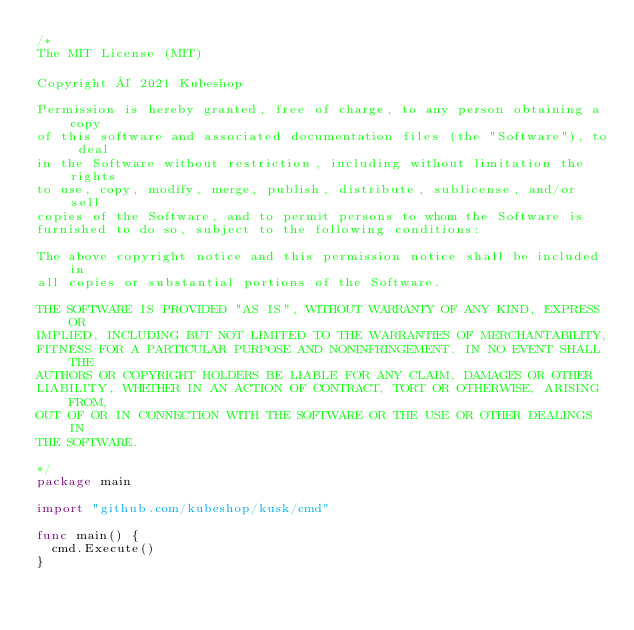<code> <loc_0><loc_0><loc_500><loc_500><_Go_>/*
The MIT License (MIT)

Copyright © 2021 Kubeshop

Permission is hereby granted, free of charge, to any person obtaining a copy
of this software and associated documentation files (the "Software"), to deal
in the Software without restriction, including without limitation the rights
to use, copy, modify, merge, publish, distribute, sublicense, and/or sell
copies of the Software, and to permit persons to whom the Software is
furnished to do so, subject to the following conditions:

The above copyright notice and this permission notice shall be included in
all copies or substantial portions of the Software.

THE SOFTWARE IS PROVIDED "AS IS", WITHOUT WARRANTY OF ANY KIND, EXPRESS OR
IMPLIED, INCLUDING BUT NOT LIMITED TO THE WARRANTIES OF MERCHANTABILITY,
FITNESS FOR A PARTICULAR PURPOSE AND NONINFRINGEMENT. IN NO EVENT SHALL THE
AUTHORS OR COPYRIGHT HOLDERS BE LIABLE FOR ANY CLAIM, DAMAGES OR OTHER
LIABILITY, WHETHER IN AN ACTION OF CONTRACT, TORT OR OTHERWISE, ARISING FROM,
OUT OF OR IN CONNECTION WITH THE SOFTWARE OR THE USE OR OTHER DEALINGS IN
THE SOFTWARE.

*/
package main

import "github.com/kubeshop/kusk/cmd"

func main() {
	cmd.Execute()
}
</code> 